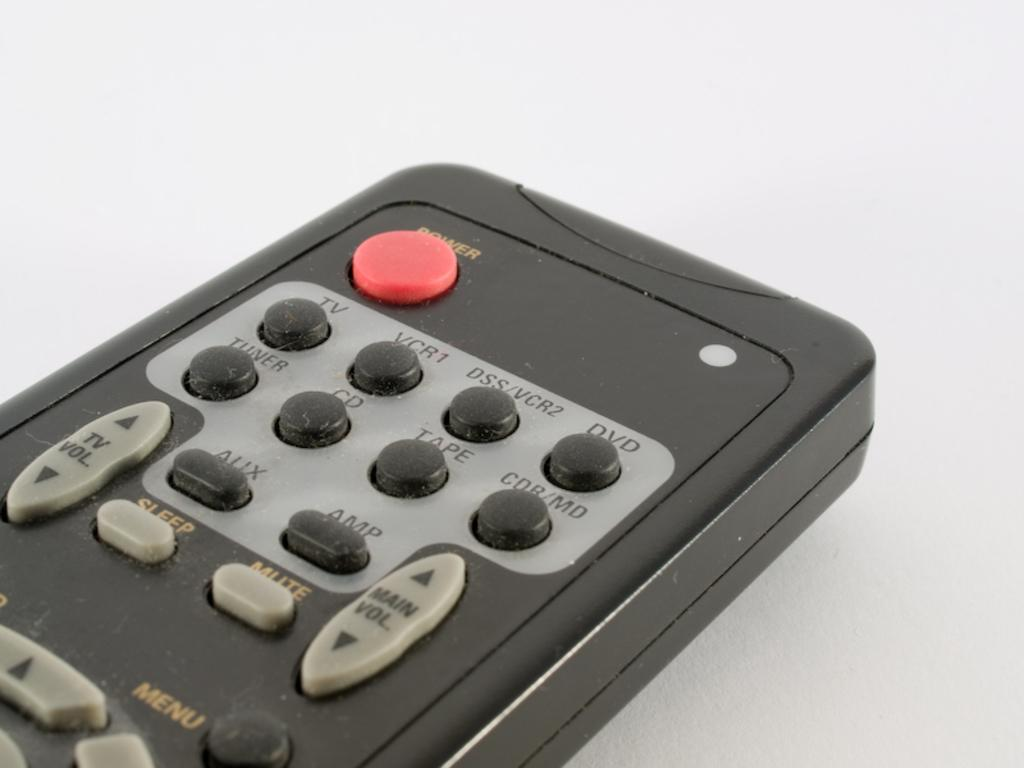<image>
Provide a brief description of the given image. a remote control with the letters AUX on it 